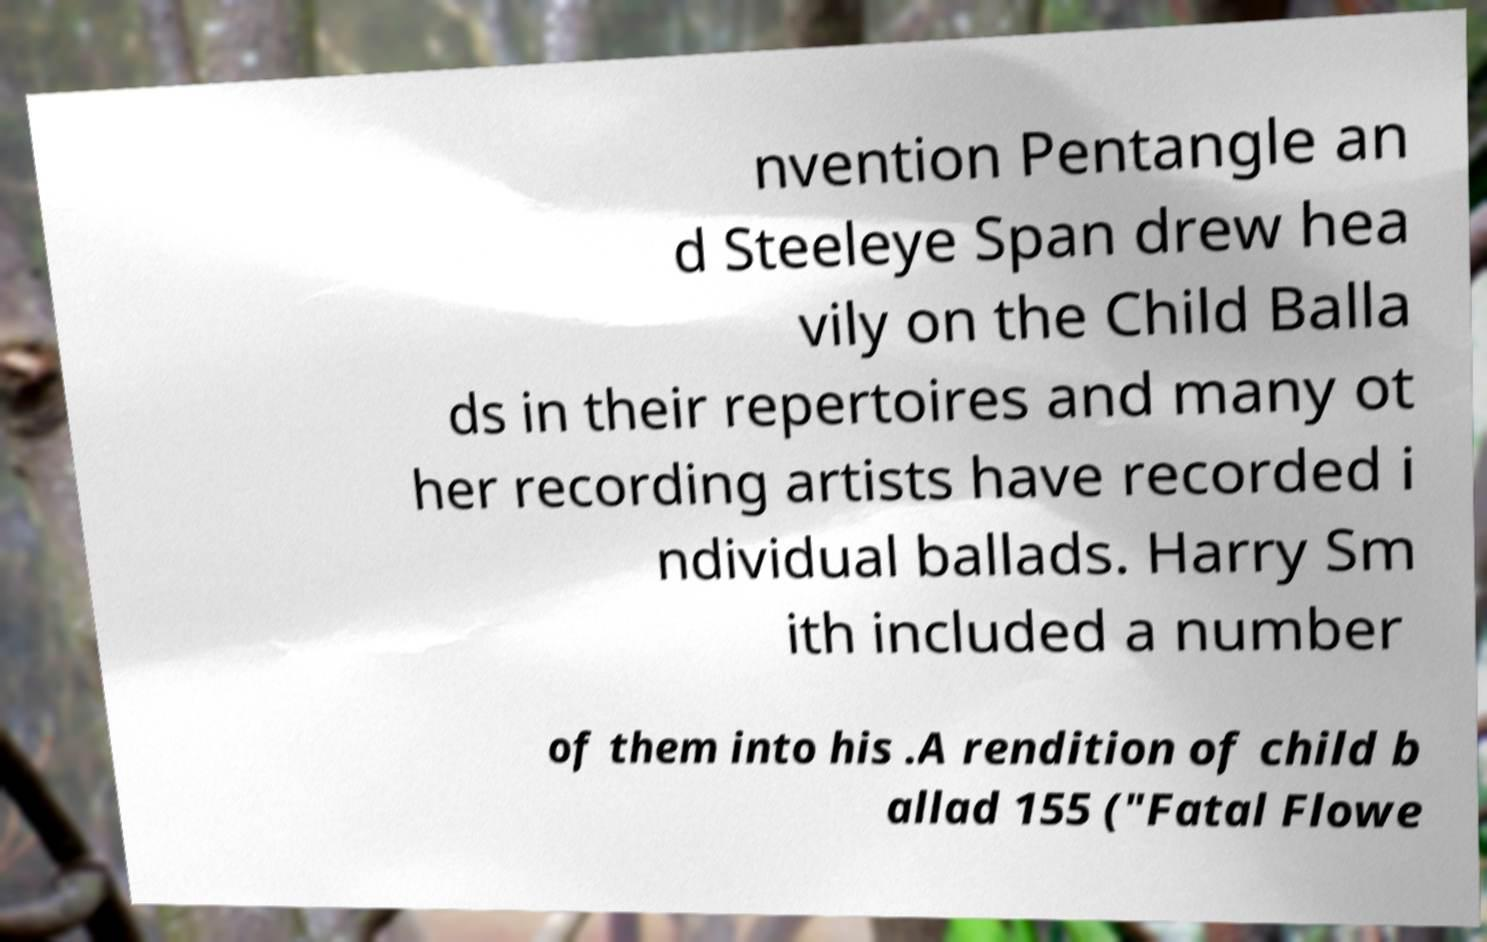What messages or text are displayed in this image? I need them in a readable, typed format. nvention Pentangle an d Steeleye Span drew hea vily on the Child Balla ds in their repertoires and many ot her recording artists have recorded i ndividual ballads. Harry Sm ith included a number of them into his .A rendition of child b allad 155 ("Fatal Flowe 